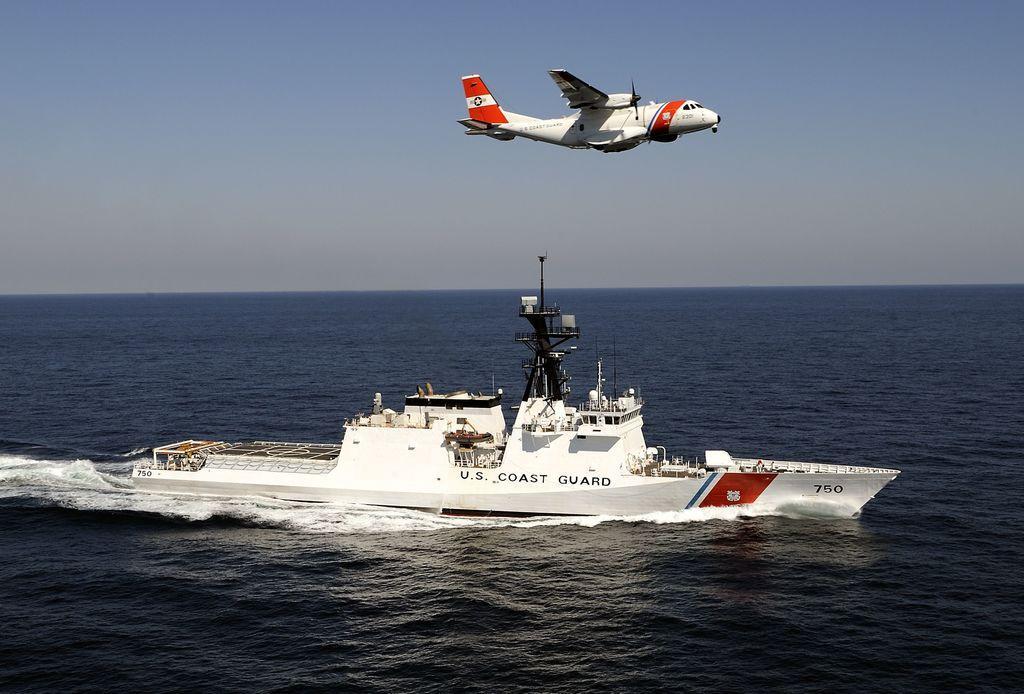Can you describe this image briefly? In this image, we can see a ship is sailing on the water. Top of the image, we can see an aircraft in the air. Here we can see the sky. 